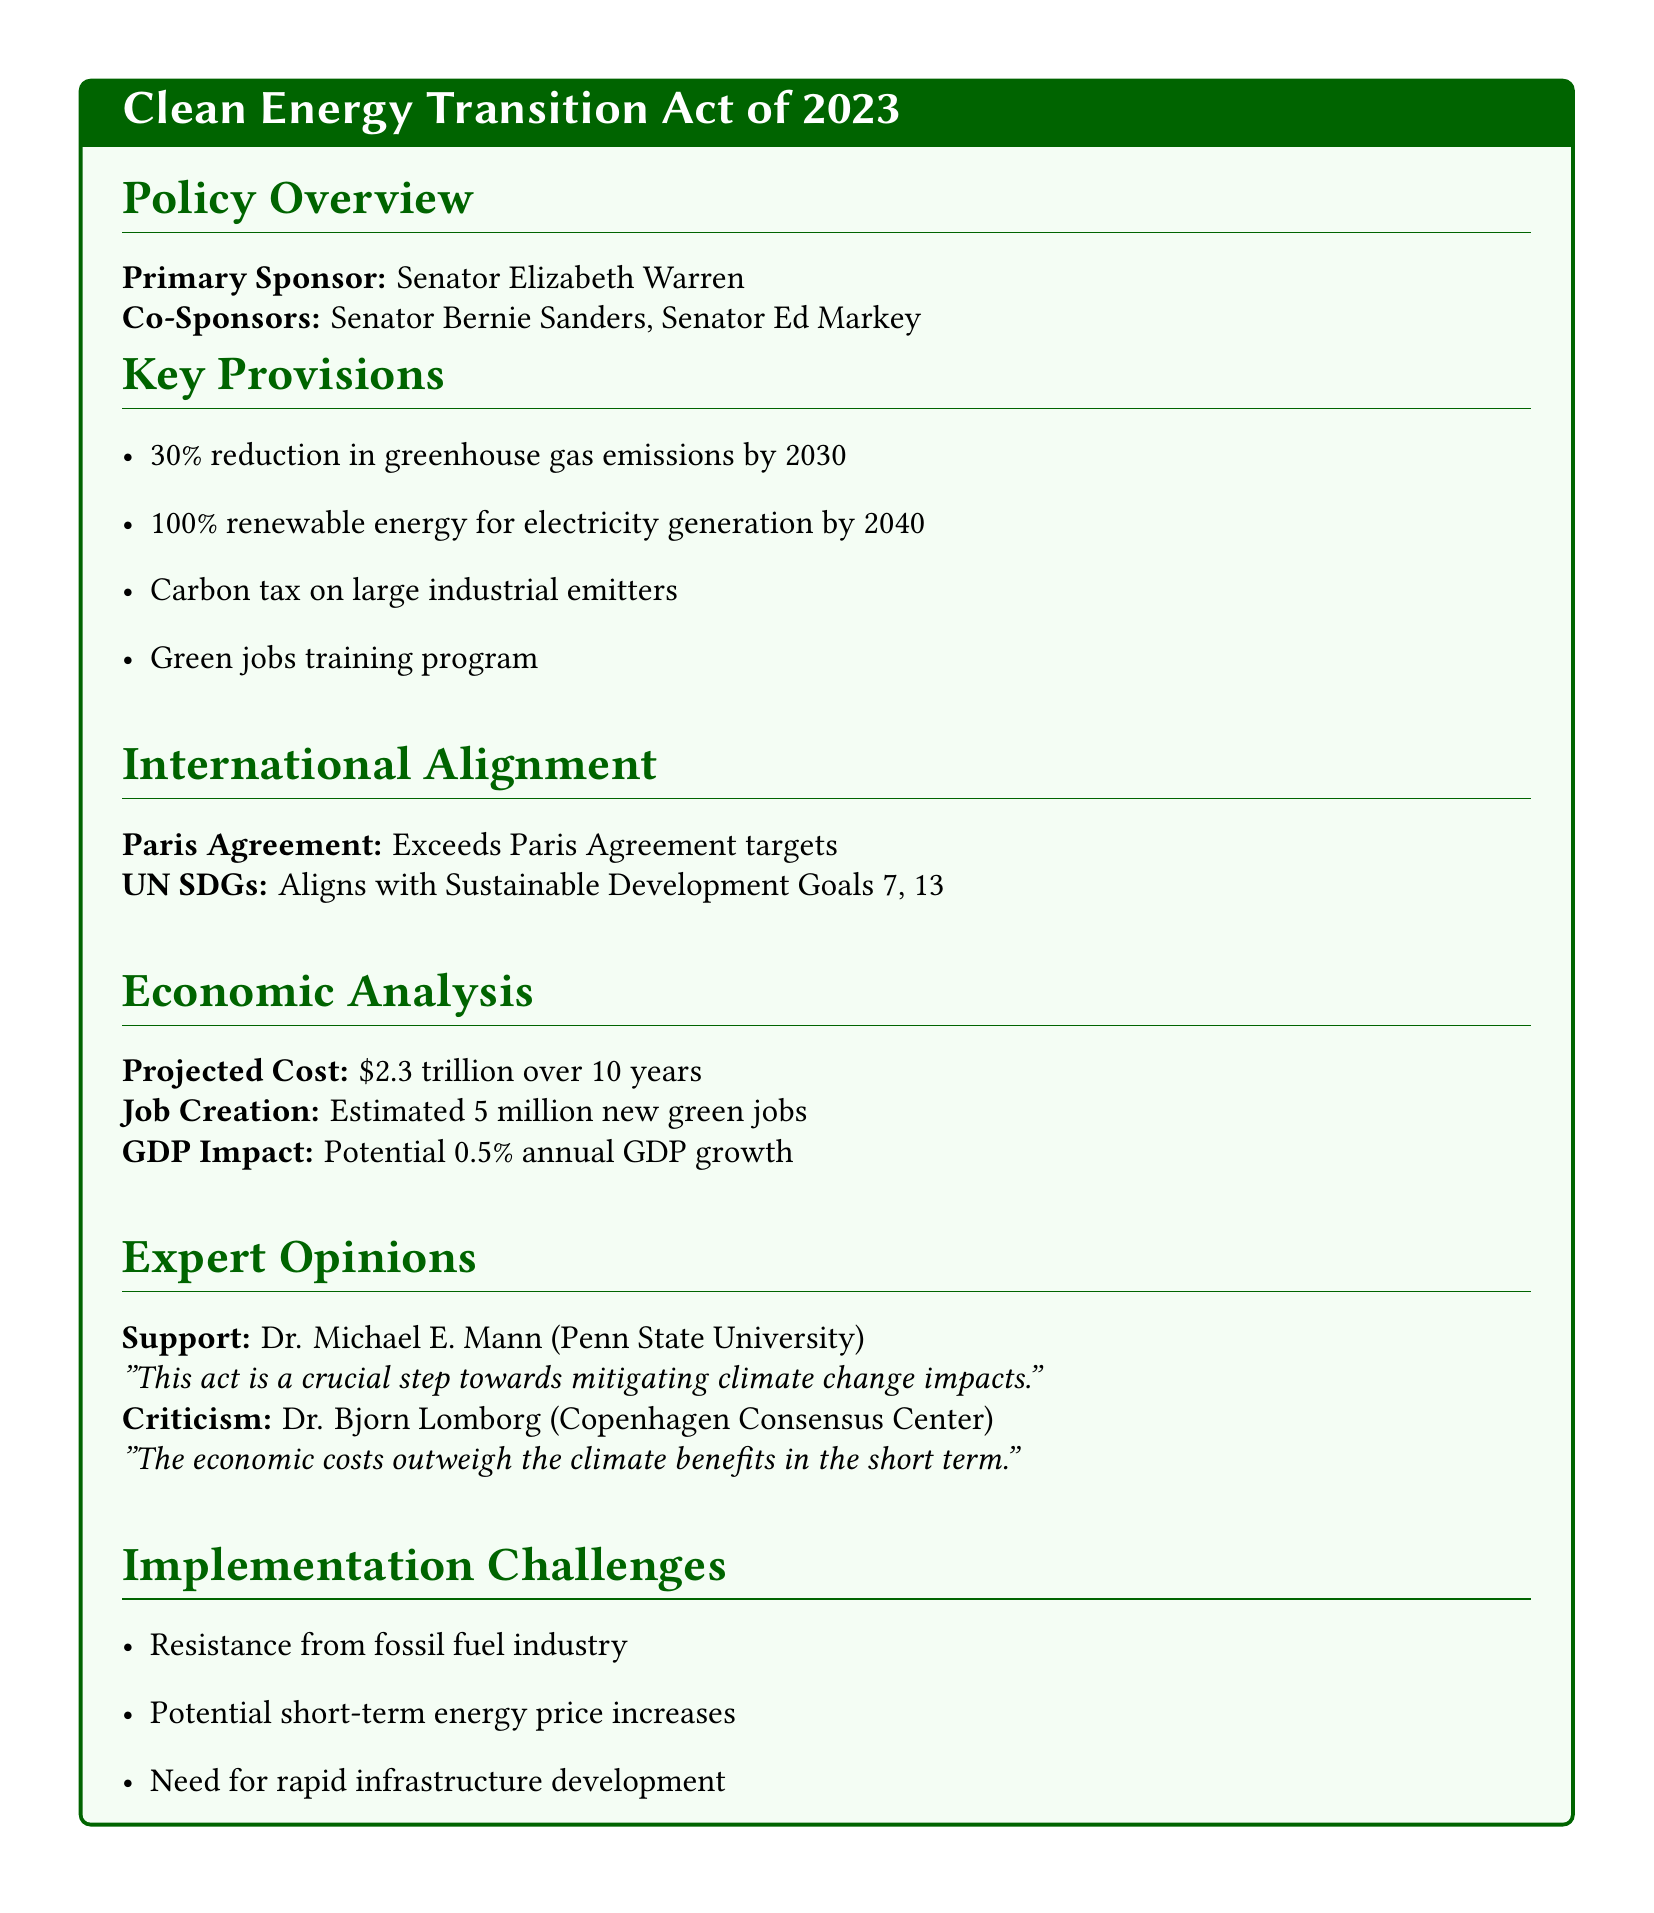What is the primary aim of the Clean Energy Transition Act? The primary aim is a 30% reduction in greenhouse gas emissions by 2030.
Answer: 30% reduction in greenhouse gas emissions by 2030 What is the projected cost of the policy? The projected cost for the implementation of the policy is mentioned in the economic analysis section.
Answer: $2.3 trillion over 10 years How many new green jobs are estimated to be created? The document provides an estimate of job creation within the economic analysis section.
Answer: 5 million new green jobs Which international agreement does the Act exceed in targets? The international agreement is referenced in the international alignment section of the document.
Answer: Paris Agreement What potential annual GDP growth is associated with this act? The potential impact on GDP is outlined in the economic analysis part of the document.
Answer: 0.5% annual GDP growth Who is a supporter of the Clean Energy Transition Act? The supporter’s name and affiliation are listed in the expert opinions section.
Answer: Dr. Michael E. Mann What challenge is highlighted regarding the fossil fuel industry? The document lists implementation challenges, including issues related to the industry.
Answer: Resistance from fossil fuel industry What is a criticism mentioned regarding the economic impact of the act? A specific criticism regarding economic costs and climate benefits is stated in the expert opinions.
Answer: The economic costs outweigh the climate benefits in the short term What is the target year for achieving 100% renewable energy for electricity generation? This target year is specified in the key provisions of the policy overview.
Answer: 2040 